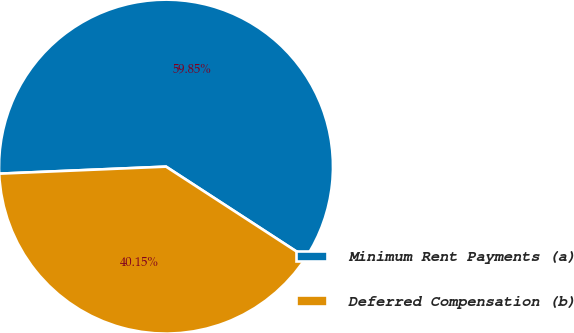Convert chart to OTSL. <chart><loc_0><loc_0><loc_500><loc_500><pie_chart><fcel>Minimum Rent Payments (a)<fcel>Deferred Compensation (b)<nl><fcel>59.85%<fcel>40.15%<nl></chart> 